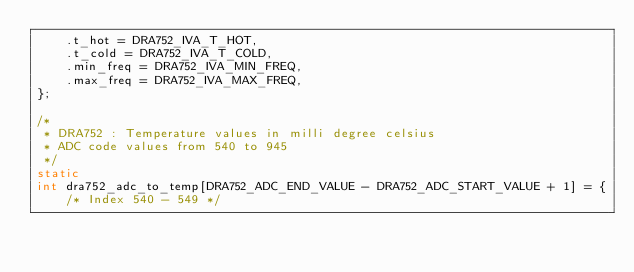<code> <loc_0><loc_0><loc_500><loc_500><_C_>	.t_hot = DRA752_IVA_T_HOT,
	.t_cold = DRA752_IVA_T_COLD,
	.min_freq = DRA752_IVA_MIN_FREQ,
	.max_freq = DRA752_IVA_MAX_FREQ,
};

/*
 * DRA752 : Temperature values in milli degree celsius
 * ADC code values from 540 to 945
 */
static
int dra752_adc_to_temp[DRA752_ADC_END_VALUE - DRA752_ADC_START_VALUE + 1] = {
	/* Index 540 - 549 */</code> 